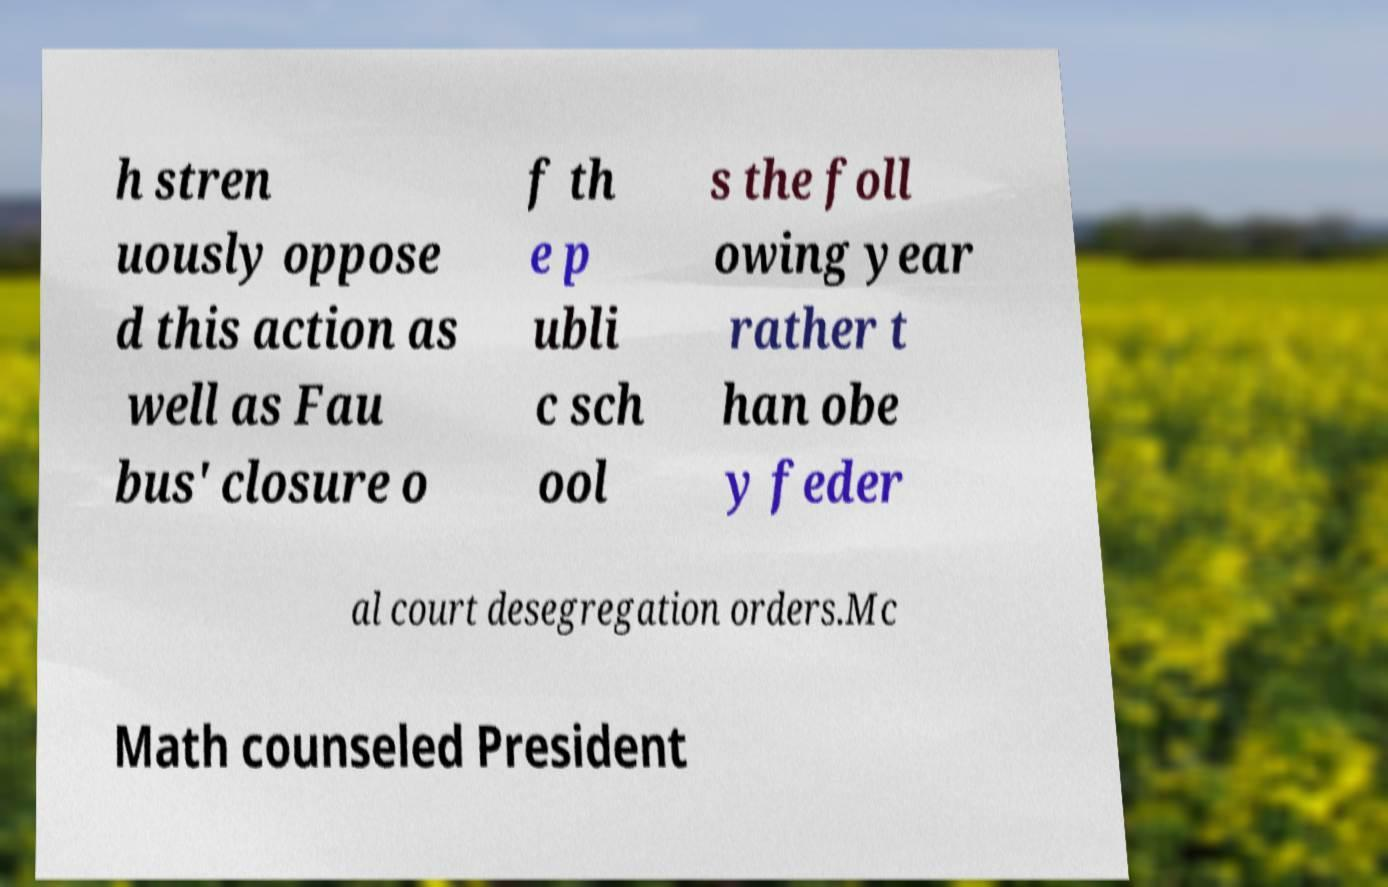For documentation purposes, I need the text within this image transcribed. Could you provide that? h stren uously oppose d this action as well as Fau bus' closure o f th e p ubli c sch ool s the foll owing year rather t han obe y feder al court desegregation orders.Mc Math counseled President 